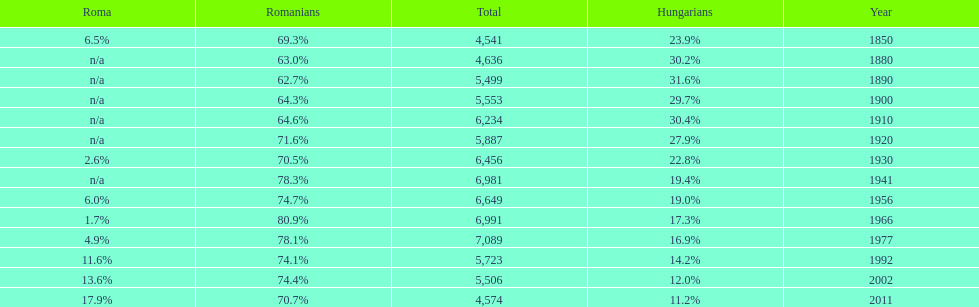What year had the next highest percentage for roma after 2011? 2002. Parse the full table. {'header': ['Roma', 'Romanians', 'Total', 'Hungarians', 'Year'], 'rows': [['6.5%', '69.3%', '4,541', '23.9%', '1850'], ['n/a', '63.0%', '4,636', '30.2%', '1880'], ['n/a', '62.7%', '5,499', '31.6%', '1890'], ['n/a', '64.3%', '5,553', '29.7%', '1900'], ['n/a', '64.6%', '6,234', '30.4%', '1910'], ['n/a', '71.6%', '5,887', '27.9%', '1920'], ['2.6%', '70.5%', '6,456', '22.8%', '1930'], ['n/a', '78.3%', '6,981', '19.4%', '1941'], ['6.0%', '74.7%', '6,649', '19.0%', '1956'], ['1.7%', '80.9%', '6,991', '17.3%', '1966'], ['4.9%', '78.1%', '7,089', '16.9%', '1977'], ['11.6%', '74.1%', '5,723', '14.2%', '1992'], ['13.6%', '74.4%', '5,506', '12.0%', '2002'], ['17.9%', '70.7%', '4,574', '11.2%', '2011']]} 